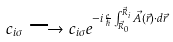Convert formula to latex. <formula><loc_0><loc_0><loc_500><loc_500>c _ { i \sigma } \longrightarrow c _ { i \sigma } e ^ { - i \frac { e } { \hslash } \int _ { \vec { R } _ { 0 } } ^ { \vec { R } _ { i } } \vec { A } ( \vec { r } ) \cdot d \vec { r } }</formula> 